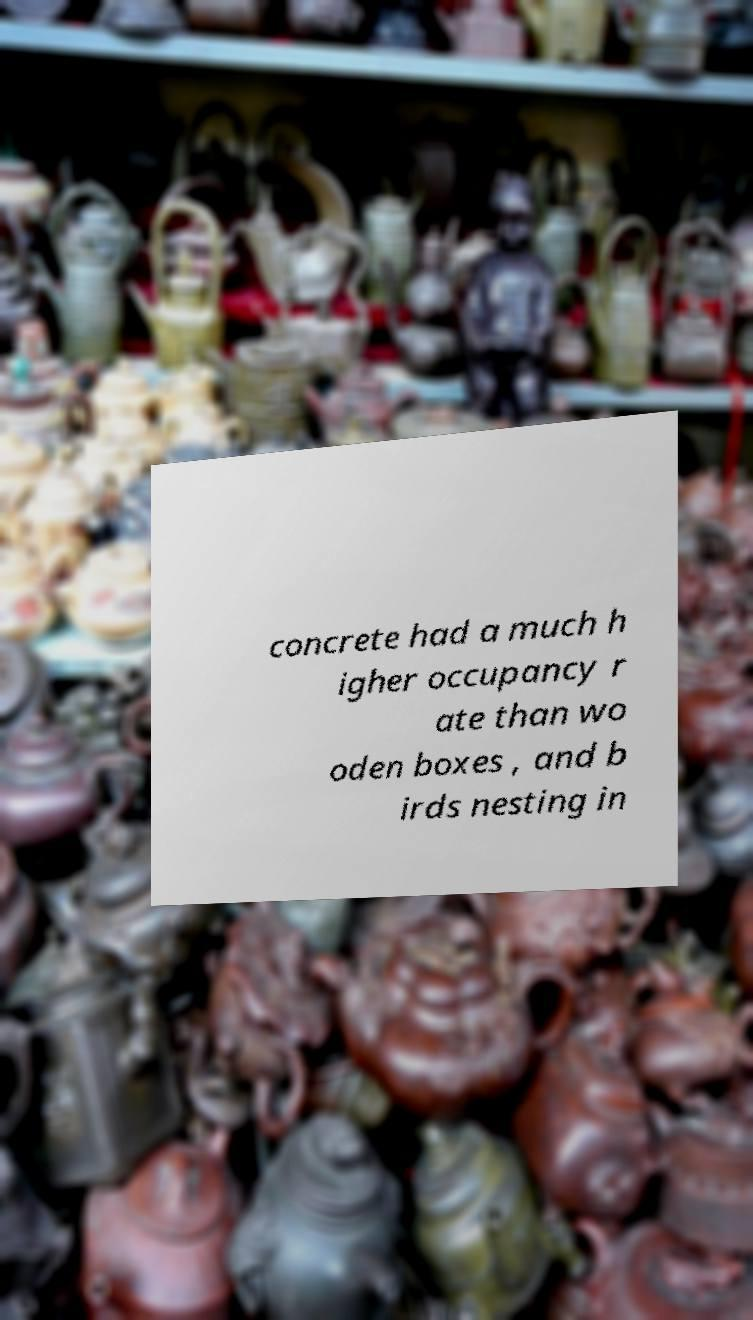I need the written content from this picture converted into text. Can you do that? concrete had a much h igher occupancy r ate than wo oden boxes , and b irds nesting in 